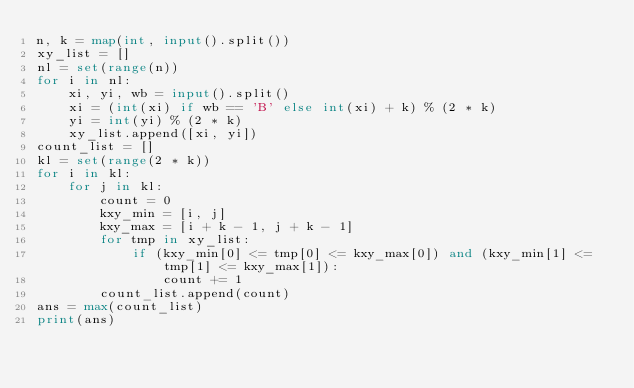Convert code to text. <code><loc_0><loc_0><loc_500><loc_500><_Python_>n, k = map(int, input().split())
xy_list = []
nl = set(range(n))
for i in nl:
    xi, yi, wb = input().split()
    xi = (int(xi) if wb == 'B' else int(xi) + k) % (2 * k)
    yi = int(yi) % (2 * k)
    xy_list.append([xi, yi])
count_list = []
kl = set(range(2 * k))
for i in kl:
    for j in kl:
        count = 0
        kxy_min = [i, j]
        kxy_max = [i + k - 1, j + k - 1]
        for tmp in xy_list:
            if (kxy_min[0] <= tmp[0] <= kxy_max[0]) and (kxy_min[1] <= tmp[1] <= kxy_max[1]):
                count += 1
        count_list.append(count)
ans = max(count_list)
print(ans)</code> 